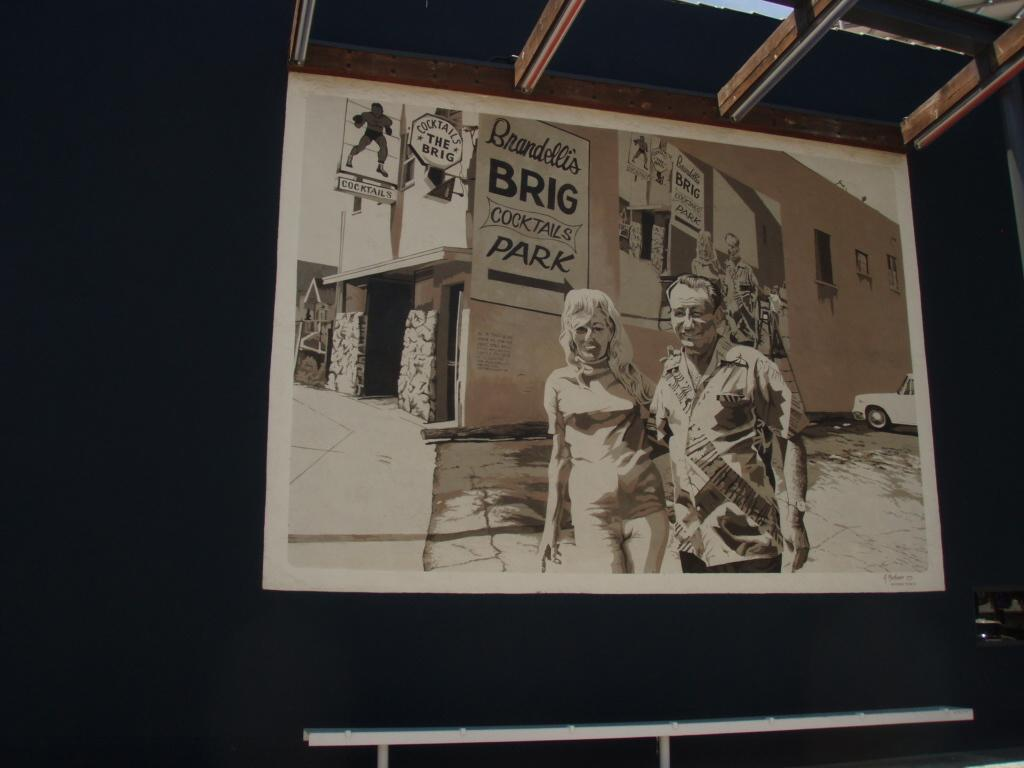<image>
Provide a brief description of the given image. The arrow is pointing to where people need to park. 